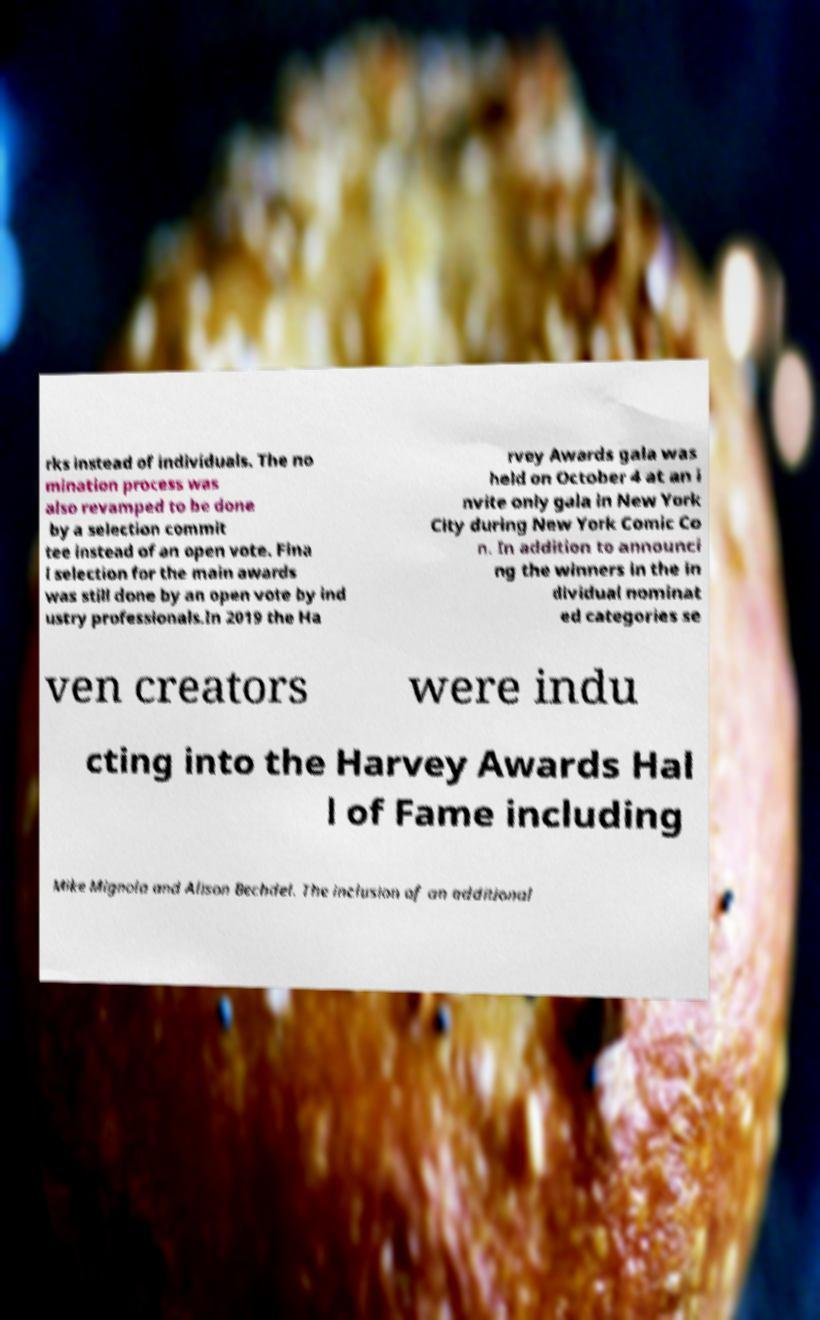Could you extract and type out the text from this image? rks instead of individuals. The no mination process was also revamped to be done by a selection commit tee instead of an open vote. Fina l selection for the main awards was still done by an open vote by ind ustry professionals.In 2019 the Ha rvey Awards gala was held on October 4 at an i nvite only gala in New York City during New York Comic Co n. In addition to announci ng the winners in the in dividual nominat ed categories se ven creators were indu cting into the Harvey Awards Hal l of Fame including Mike Mignola and Alison Bechdel. The inclusion of an additional 